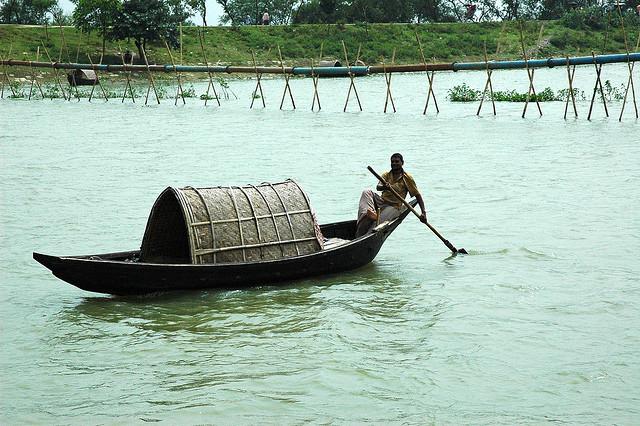What might this body of water be called?
Quick response, please. River. Is the water smooth?
Keep it brief. Yes. What kind of boat is the man in?
Write a very short answer. Canoe. 